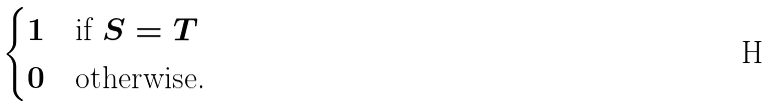Convert formula to latex. <formula><loc_0><loc_0><loc_500><loc_500>\begin{cases} 1 & \text {if } S = T \\ 0 & \text {otherwise.} \end{cases}</formula> 